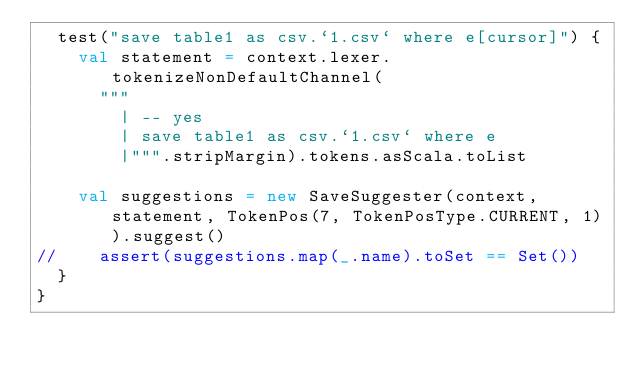<code> <loc_0><loc_0><loc_500><loc_500><_Scala_>  test("save table1 as csv.`1.csv` where e[cursor]") {
    val statement = context.lexer.tokenizeNonDefaultChannel(
      """
        | -- yes
        | save table1 as csv.`1.csv` where e
        |""".stripMargin).tokens.asScala.toList

    val suggestions = new SaveSuggester(context, statement, TokenPos(7, TokenPosType.CURRENT, 1)).suggest()
//    assert(suggestions.map(_.name).toSet == Set())
  }
}
</code> 